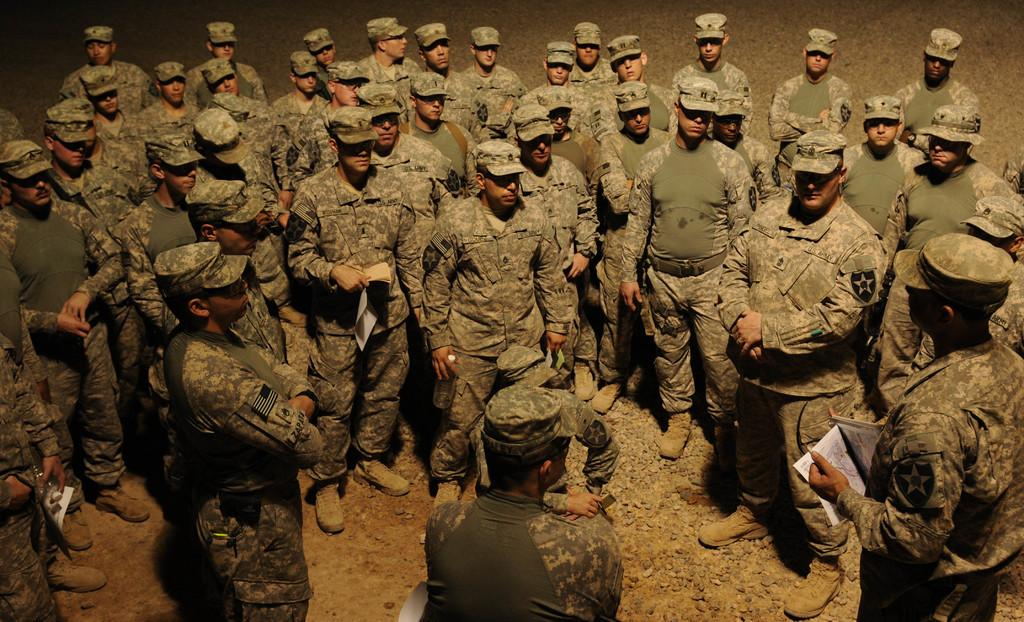How many individuals are present in the image? There are many people in the image. What is the surface beneath the people's feet? The people are standing on the ground. What objects are being held by some of the people in the image? Some people are holding papers in their hands. What type of wine is being served at the event in the image? There is no mention of wine or an event in the image; it simply shows a group of people standing on the ground with some holding papers. 